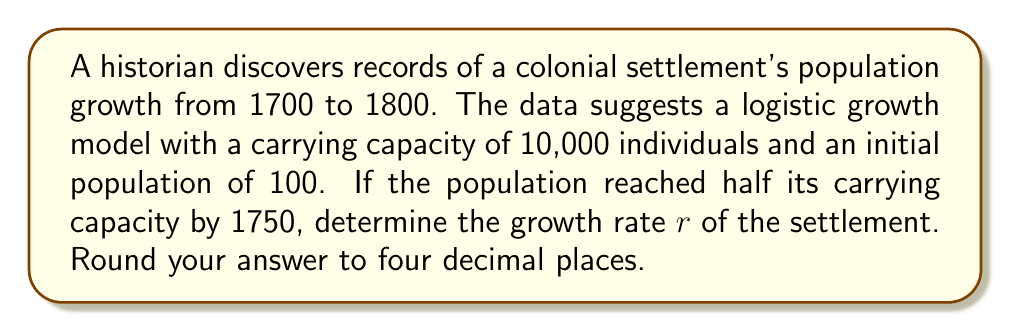Teach me how to tackle this problem. To solve this problem, we'll use the logistic growth model and the given information. Let's approach this step-by-step:

1) The logistic growth model is given by the equation:

   $$P(t) = \frac{K}{1 + (\frac{K}{P_0} - 1)e^{-rt}}$$

   Where:
   $P(t)$ is the population at time $t$
   $K$ is the carrying capacity
   $P_0$ is the initial population
   $r$ is the growth rate
   $t$ is the time

2) We're given:
   $K = 10,000$
   $P_0 = 100$
   At $t = 50$ (1750), $P(50) = 5,000$ (half the carrying capacity)

3) Let's substitute these values into the equation:

   $$5000 = \frac{10000}{1 + (\frac{10000}{100} - 1)e^{-50r}}$$

4) Simplify:

   $$5000 = \frac{10000}{1 + 99e^{-50r}}$$

5) Multiply both sides by $(1 + 99e^{-50r})$:

   $$5000(1 + 99e^{-50r}) = 10000$$

6) Expand:

   $$5000 + 495000e^{-50r} = 10000$$

7) Subtract 5000 from both sides:

   $$495000e^{-50r} = 5000$$

8) Divide both sides by 495000:

   $$e^{-50r} = \frac{1}{99}$$

9) Take the natural log of both sides:

   $$-50r = \ln(\frac{1}{99})$$

10) Solve for $r$:

    $$r = -\frac{1}{50}\ln(\frac{1}{99}) = \frac{\ln(99)}{50} \approx 0.0921$$

11) Rounding to four decimal places:

    $$r \approx 0.0921$$
Answer: 0.0921 